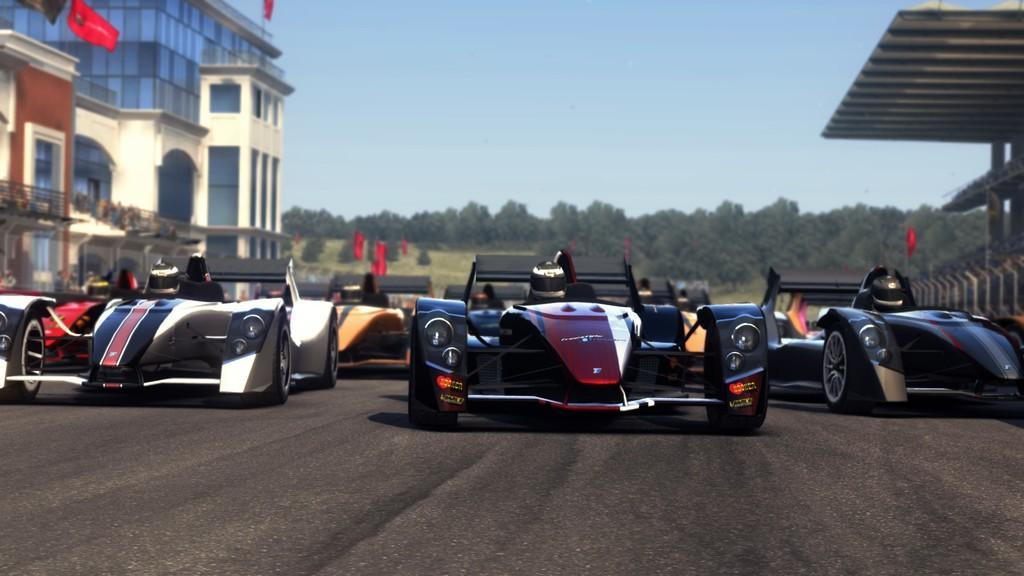How would you summarize this image in a sentence or two? In this image we can see sports cars on the road and there are people in the cars. In the background there are buildings, trees, flags and sky. 